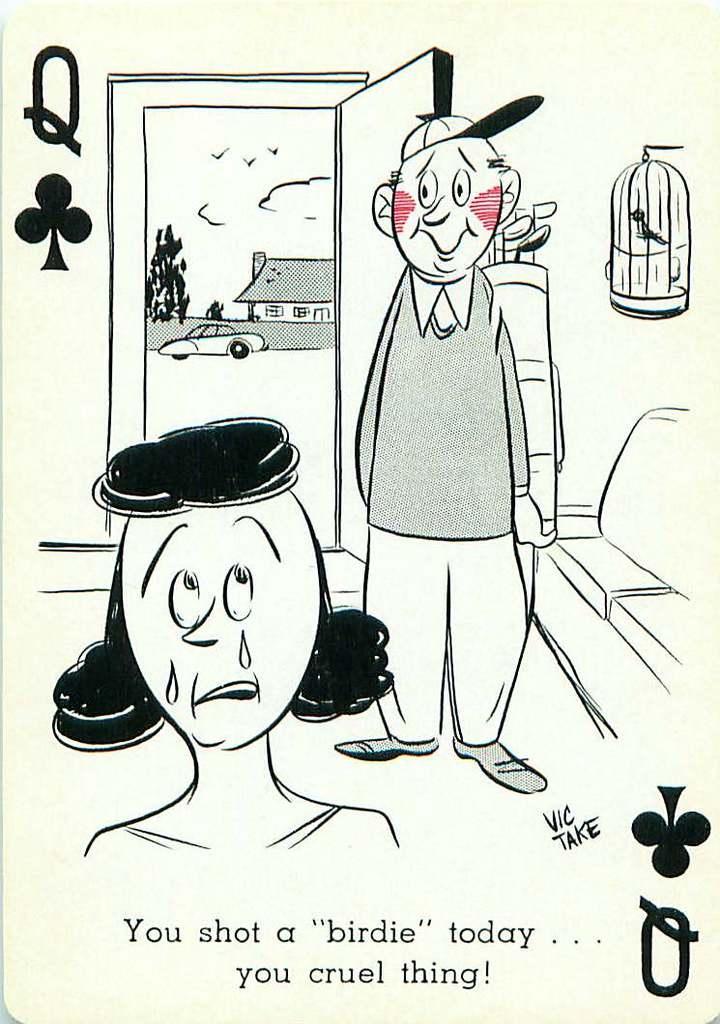Describe this image in one or two sentences. In this image I can see two cartoon persons and I can see a cage, a vehicle, a house and few birds. 